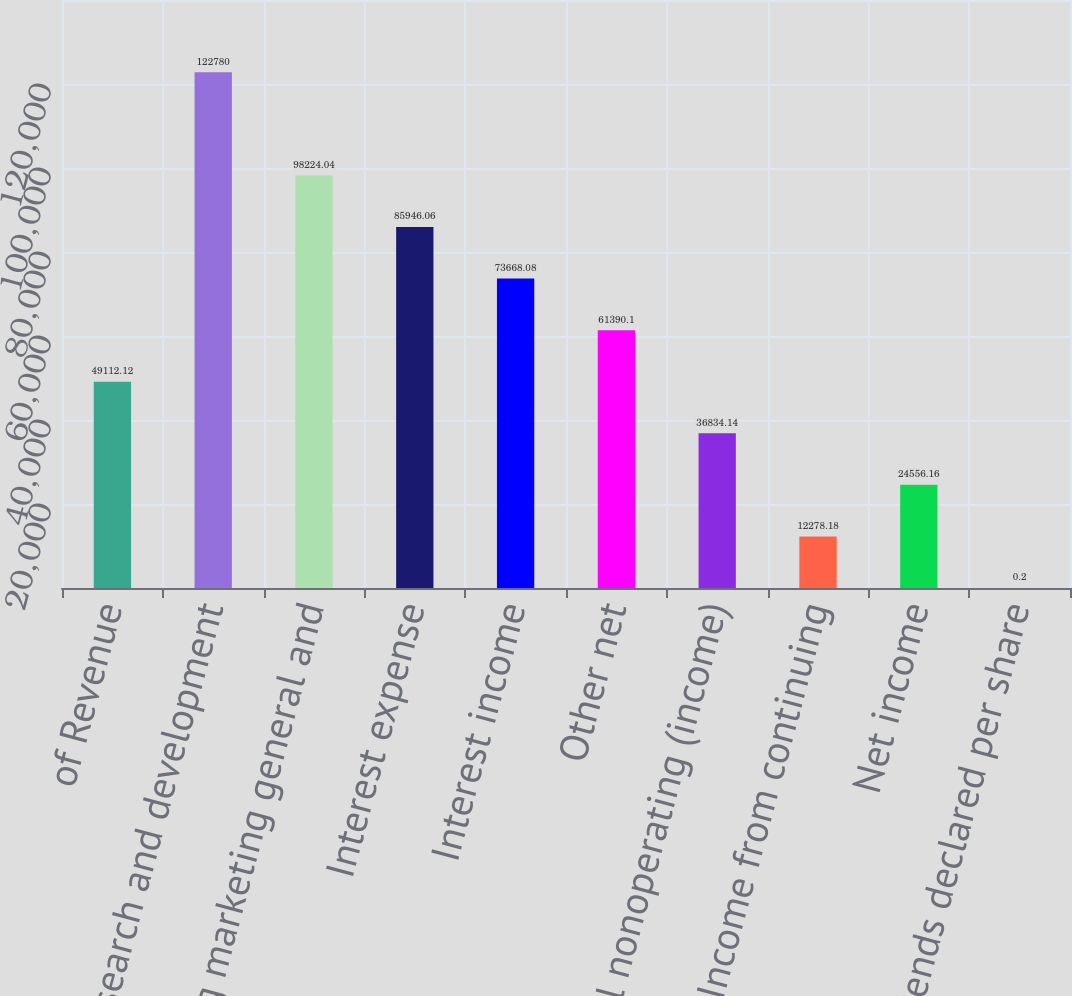Convert chart. <chart><loc_0><loc_0><loc_500><loc_500><bar_chart><fcel>of Revenue<fcel>Research and development<fcel>Selling marketing general and<fcel>Interest expense<fcel>Interest income<fcel>Other net<fcel>Total nonoperating (income)<fcel>Income from continuing<fcel>Net income<fcel>Dividends declared per share<nl><fcel>49112.1<fcel>122780<fcel>98224<fcel>85946.1<fcel>73668.1<fcel>61390.1<fcel>36834.1<fcel>12278.2<fcel>24556.2<fcel>0.2<nl></chart> 